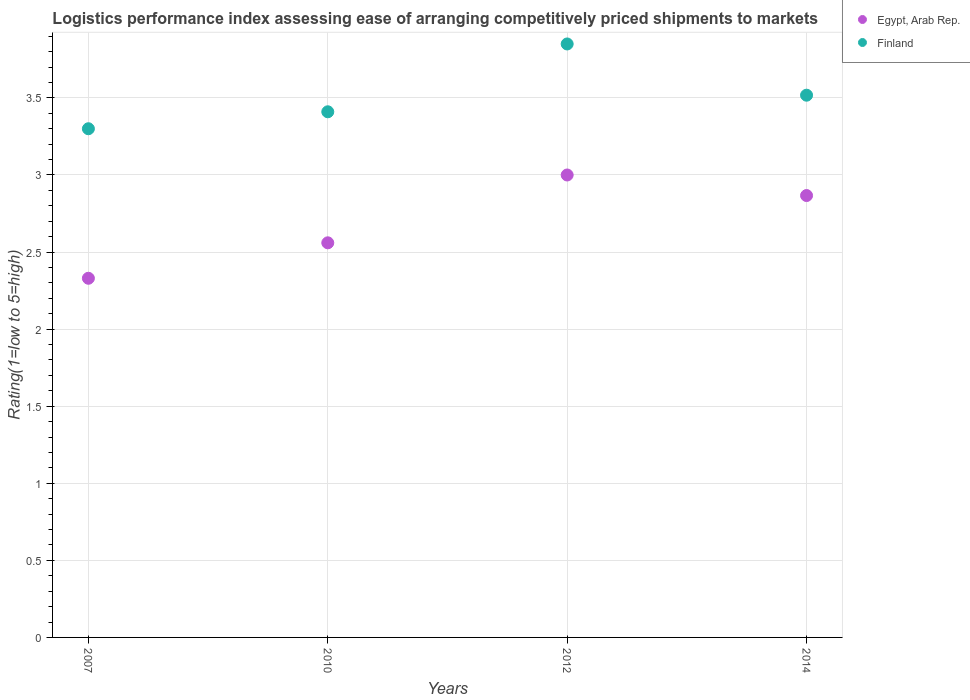Across all years, what is the maximum Logistic performance index in Finland?
Keep it short and to the point. 3.85. In which year was the Logistic performance index in Finland maximum?
Your response must be concise. 2012. In which year was the Logistic performance index in Egypt, Arab Rep. minimum?
Your response must be concise. 2007. What is the total Logistic performance index in Finland in the graph?
Your answer should be compact. 14.08. What is the difference between the Logistic performance index in Finland in 2007 and that in 2012?
Your answer should be compact. -0.55. What is the difference between the Logistic performance index in Egypt, Arab Rep. in 2010 and the Logistic performance index in Finland in 2007?
Provide a short and direct response. -0.74. What is the average Logistic performance index in Finland per year?
Your response must be concise. 3.52. In the year 2010, what is the difference between the Logistic performance index in Egypt, Arab Rep. and Logistic performance index in Finland?
Your response must be concise. -0.85. In how many years, is the Logistic performance index in Finland greater than 3.4?
Your answer should be very brief. 3. What is the ratio of the Logistic performance index in Egypt, Arab Rep. in 2010 to that in 2014?
Make the answer very short. 0.89. Is the Logistic performance index in Egypt, Arab Rep. in 2007 less than that in 2012?
Your answer should be very brief. Yes. Is the difference between the Logistic performance index in Egypt, Arab Rep. in 2010 and 2014 greater than the difference between the Logistic performance index in Finland in 2010 and 2014?
Offer a very short reply. No. What is the difference between the highest and the second highest Logistic performance index in Egypt, Arab Rep.?
Ensure brevity in your answer.  0.13. What is the difference between the highest and the lowest Logistic performance index in Finland?
Your answer should be compact. 0.55. In how many years, is the Logistic performance index in Finland greater than the average Logistic performance index in Finland taken over all years?
Give a very brief answer. 1. Is the sum of the Logistic performance index in Egypt, Arab Rep. in 2010 and 2012 greater than the maximum Logistic performance index in Finland across all years?
Provide a short and direct response. Yes. Does the Logistic performance index in Egypt, Arab Rep. monotonically increase over the years?
Provide a short and direct response. No. Is the Logistic performance index in Egypt, Arab Rep. strictly less than the Logistic performance index in Finland over the years?
Make the answer very short. Yes. How many years are there in the graph?
Keep it short and to the point. 4. Where does the legend appear in the graph?
Provide a short and direct response. Top right. How many legend labels are there?
Provide a short and direct response. 2. How are the legend labels stacked?
Offer a very short reply. Vertical. What is the title of the graph?
Keep it short and to the point. Logistics performance index assessing ease of arranging competitively priced shipments to markets. What is the label or title of the Y-axis?
Keep it short and to the point. Rating(1=low to 5=high). What is the Rating(1=low to 5=high) in Egypt, Arab Rep. in 2007?
Offer a terse response. 2.33. What is the Rating(1=low to 5=high) of Finland in 2007?
Your response must be concise. 3.3. What is the Rating(1=low to 5=high) of Egypt, Arab Rep. in 2010?
Offer a very short reply. 2.56. What is the Rating(1=low to 5=high) in Finland in 2010?
Your answer should be compact. 3.41. What is the Rating(1=low to 5=high) in Egypt, Arab Rep. in 2012?
Provide a succinct answer. 3. What is the Rating(1=low to 5=high) in Finland in 2012?
Give a very brief answer. 3.85. What is the Rating(1=low to 5=high) of Egypt, Arab Rep. in 2014?
Give a very brief answer. 2.87. What is the Rating(1=low to 5=high) in Finland in 2014?
Keep it short and to the point. 3.52. Across all years, what is the maximum Rating(1=low to 5=high) of Egypt, Arab Rep.?
Provide a succinct answer. 3. Across all years, what is the maximum Rating(1=low to 5=high) in Finland?
Provide a short and direct response. 3.85. Across all years, what is the minimum Rating(1=low to 5=high) in Egypt, Arab Rep.?
Your response must be concise. 2.33. Across all years, what is the minimum Rating(1=low to 5=high) in Finland?
Your response must be concise. 3.3. What is the total Rating(1=low to 5=high) in Egypt, Arab Rep. in the graph?
Your answer should be compact. 10.76. What is the total Rating(1=low to 5=high) in Finland in the graph?
Provide a succinct answer. 14.08. What is the difference between the Rating(1=low to 5=high) in Egypt, Arab Rep. in 2007 and that in 2010?
Make the answer very short. -0.23. What is the difference between the Rating(1=low to 5=high) of Finland in 2007 and that in 2010?
Your answer should be very brief. -0.11. What is the difference between the Rating(1=low to 5=high) of Egypt, Arab Rep. in 2007 and that in 2012?
Your answer should be compact. -0.67. What is the difference between the Rating(1=low to 5=high) in Finland in 2007 and that in 2012?
Make the answer very short. -0.55. What is the difference between the Rating(1=low to 5=high) of Egypt, Arab Rep. in 2007 and that in 2014?
Provide a succinct answer. -0.54. What is the difference between the Rating(1=low to 5=high) in Finland in 2007 and that in 2014?
Your answer should be very brief. -0.22. What is the difference between the Rating(1=low to 5=high) in Egypt, Arab Rep. in 2010 and that in 2012?
Offer a very short reply. -0.44. What is the difference between the Rating(1=low to 5=high) of Finland in 2010 and that in 2012?
Provide a short and direct response. -0.44. What is the difference between the Rating(1=low to 5=high) of Egypt, Arab Rep. in 2010 and that in 2014?
Your response must be concise. -0.31. What is the difference between the Rating(1=low to 5=high) in Finland in 2010 and that in 2014?
Ensure brevity in your answer.  -0.11. What is the difference between the Rating(1=low to 5=high) of Egypt, Arab Rep. in 2012 and that in 2014?
Offer a terse response. 0.13. What is the difference between the Rating(1=low to 5=high) of Finland in 2012 and that in 2014?
Offer a terse response. 0.33. What is the difference between the Rating(1=low to 5=high) in Egypt, Arab Rep. in 2007 and the Rating(1=low to 5=high) in Finland in 2010?
Make the answer very short. -1.08. What is the difference between the Rating(1=low to 5=high) in Egypt, Arab Rep. in 2007 and the Rating(1=low to 5=high) in Finland in 2012?
Offer a very short reply. -1.52. What is the difference between the Rating(1=low to 5=high) in Egypt, Arab Rep. in 2007 and the Rating(1=low to 5=high) in Finland in 2014?
Provide a succinct answer. -1.19. What is the difference between the Rating(1=low to 5=high) of Egypt, Arab Rep. in 2010 and the Rating(1=low to 5=high) of Finland in 2012?
Your answer should be compact. -1.29. What is the difference between the Rating(1=low to 5=high) of Egypt, Arab Rep. in 2010 and the Rating(1=low to 5=high) of Finland in 2014?
Your answer should be compact. -0.96. What is the difference between the Rating(1=low to 5=high) in Egypt, Arab Rep. in 2012 and the Rating(1=low to 5=high) in Finland in 2014?
Provide a short and direct response. -0.52. What is the average Rating(1=low to 5=high) of Egypt, Arab Rep. per year?
Make the answer very short. 2.69. What is the average Rating(1=low to 5=high) of Finland per year?
Give a very brief answer. 3.52. In the year 2007, what is the difference between the Rating(1=low to 5=high) in Egypt, Arab Rep. and Rating(1=low to 5=high) in Finland?
Provide a succinct answer. -0.97. In the year 2010, what is the difference between the Rating(1=low to 5=high) of Egypt, Arab Rep. and Rating(1=low to 5=high) of Finland?
Give a very brief answer. -0.85. In the year 2012, what is the difference between the Rating(1=low to 5=high) of Egypt, Arab Rep. and Rating(1=low to 5=high) of Finland?
Your answer should be very brief. -0.85. In the year 2014, what is the difference between the Rating(1=low to 5=high) in Egypt, Arab Rep. and Rating(1=low to 5=high) in Finland?
Keep it short and to the point. -0.65. What is the ratio of the Rating(1=low to 5=high) in Egypt, Arab Rep. in 2007 to that in 2010?
Ensure brevity in your answer.  0.91. What is the ratio of the Rating(1=low to 5=high) in Finland in 2007 to that in 2010?
Your answer should be very brief. 0.97. What is the ratio of the Rating(1=low to 5=high) in Egypt, Arab Rep. in 2007 to that in 2012?
Your answer should be very brief. 0.78. What is the ratio of the Rating(1=low to 5=high) of Egypt, Arab Rep. in 2007 to that in 2014?
Give a very brief answer. 0.81. What is the ratio of the Rating(1=low to 5=high) in Finland in 2007 to that in 2014?
Ensure brevity in your answer.  0.94. What is the ratio of the Rating(1=low to 5=high) of Egypt, Arab Rep. in 2010 to that in 2012?
Offer a very short reply. 0.85. What is the ratio of the Rating(1=low to 5=high) in Finland in 2010 to that in 2012?
Provide a succinct answer. 0.89. What is the ratio of the Rating(1=low to 5=high) in Egypt, Arab Rep. in 2010 to that in 2014?
Keep it short and to the point. 0.89. What is the ratio of the Rating(1=low to 5=high) of Finland in 2010 to that in 2014?
Make the answer very short. 0.97. What is the ratio of the Rating(1=low to 5=high) in Egypt, Arab Rep. in 2012 to that in 2014?
Keep it short and to the point. 1.05. What is the ratio of the Rating(1=low to 5=high) of Finland in 2012 to that in 2014?
Keep it short and to the point. 1.09. What is the difference between the highest and the second highest Rating(1=low to 5=high) of Egypt, Arab Rep.?
Your answer should be very brief. 0.13. What is the difference between the highest and the second highest Rating(1=low to 5=high) in Finland?
Provide a succinct answer. 0.33. What is the difference between the highest and the lowest Rating(1=low to 5=high) in Egypt, Arab Rep.?
Keep it short and to the point. 0.67. What is the difference between the highest and the lowest Rating(1=low to 5=high) of Finland?
Provide a short and direct response. 0.55. 